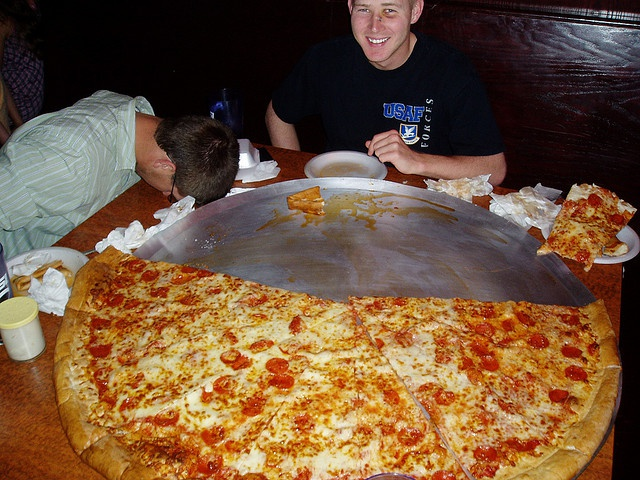Describe the objects in this image and their specific colors. I can see dining table in black, red, gray, maroon, and tan tones, pizza in black, red, tan, and maroon tones, people in black, brown, lightpink, and darkgray tones, people in black, darkgray, and gray tones, and pizza in black, brown, maroon, and tan tones in this image. 